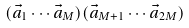Convert formula to latex. <formula><loc_0><loc_0><loc_500><loc_500>( \vec { a } _ { 1 } \cdots \vec { a } _ { M } ) ( \vec { a } _ { M + 1 } \cdots \vec { a } _ { 2 M } )</formula> 